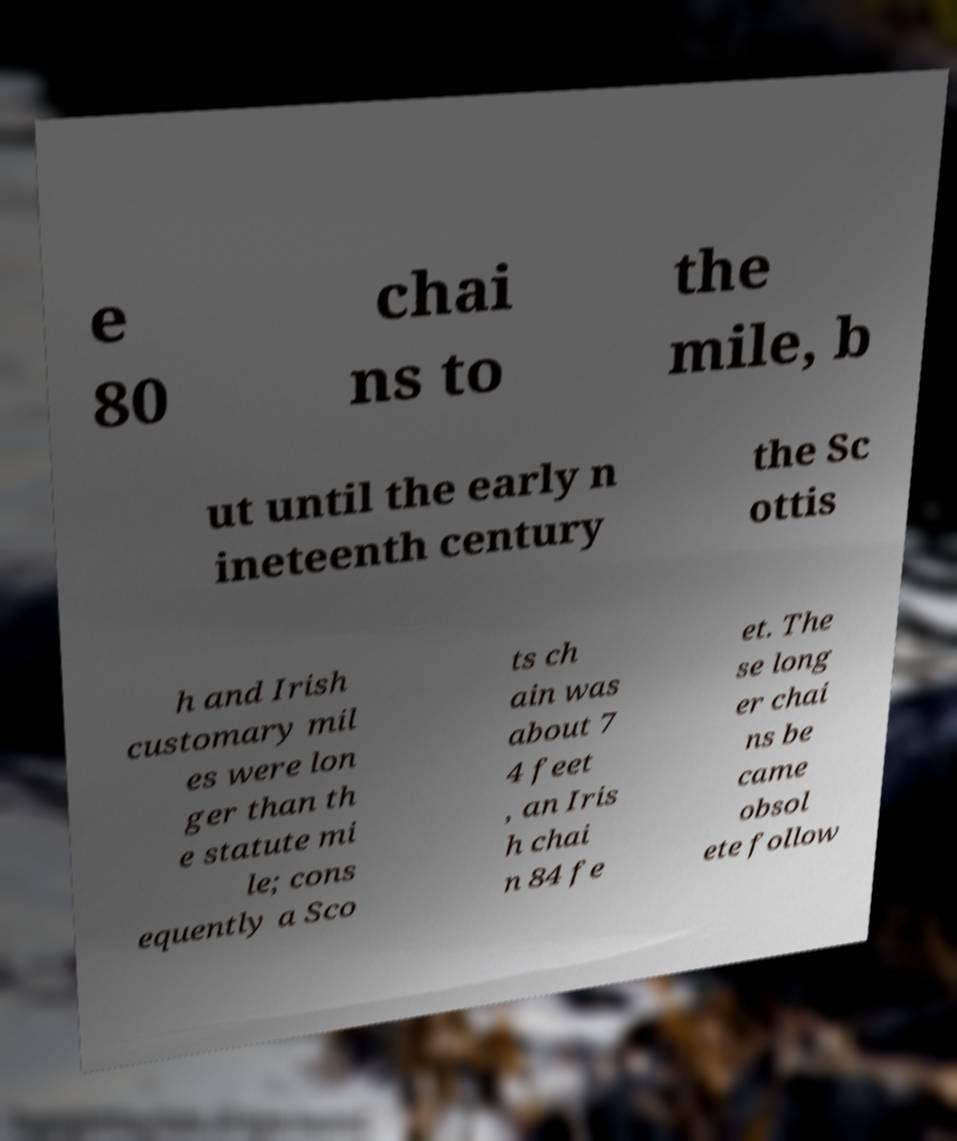Can you read and provide the text displayed in the image?This photo seems to have some interesting text. Can you extract and type it out for me? e 80 chai ns to the mile, b ut until the early n ineteenth century the Sc ottis h and Irish customary mil es were lon ger than th e statute mi le; cons equently a Sco ts ch ain was about 7 4 feet , an Iris h chai n 84 fe et. The se long er chai ns be came obsol ete follow 